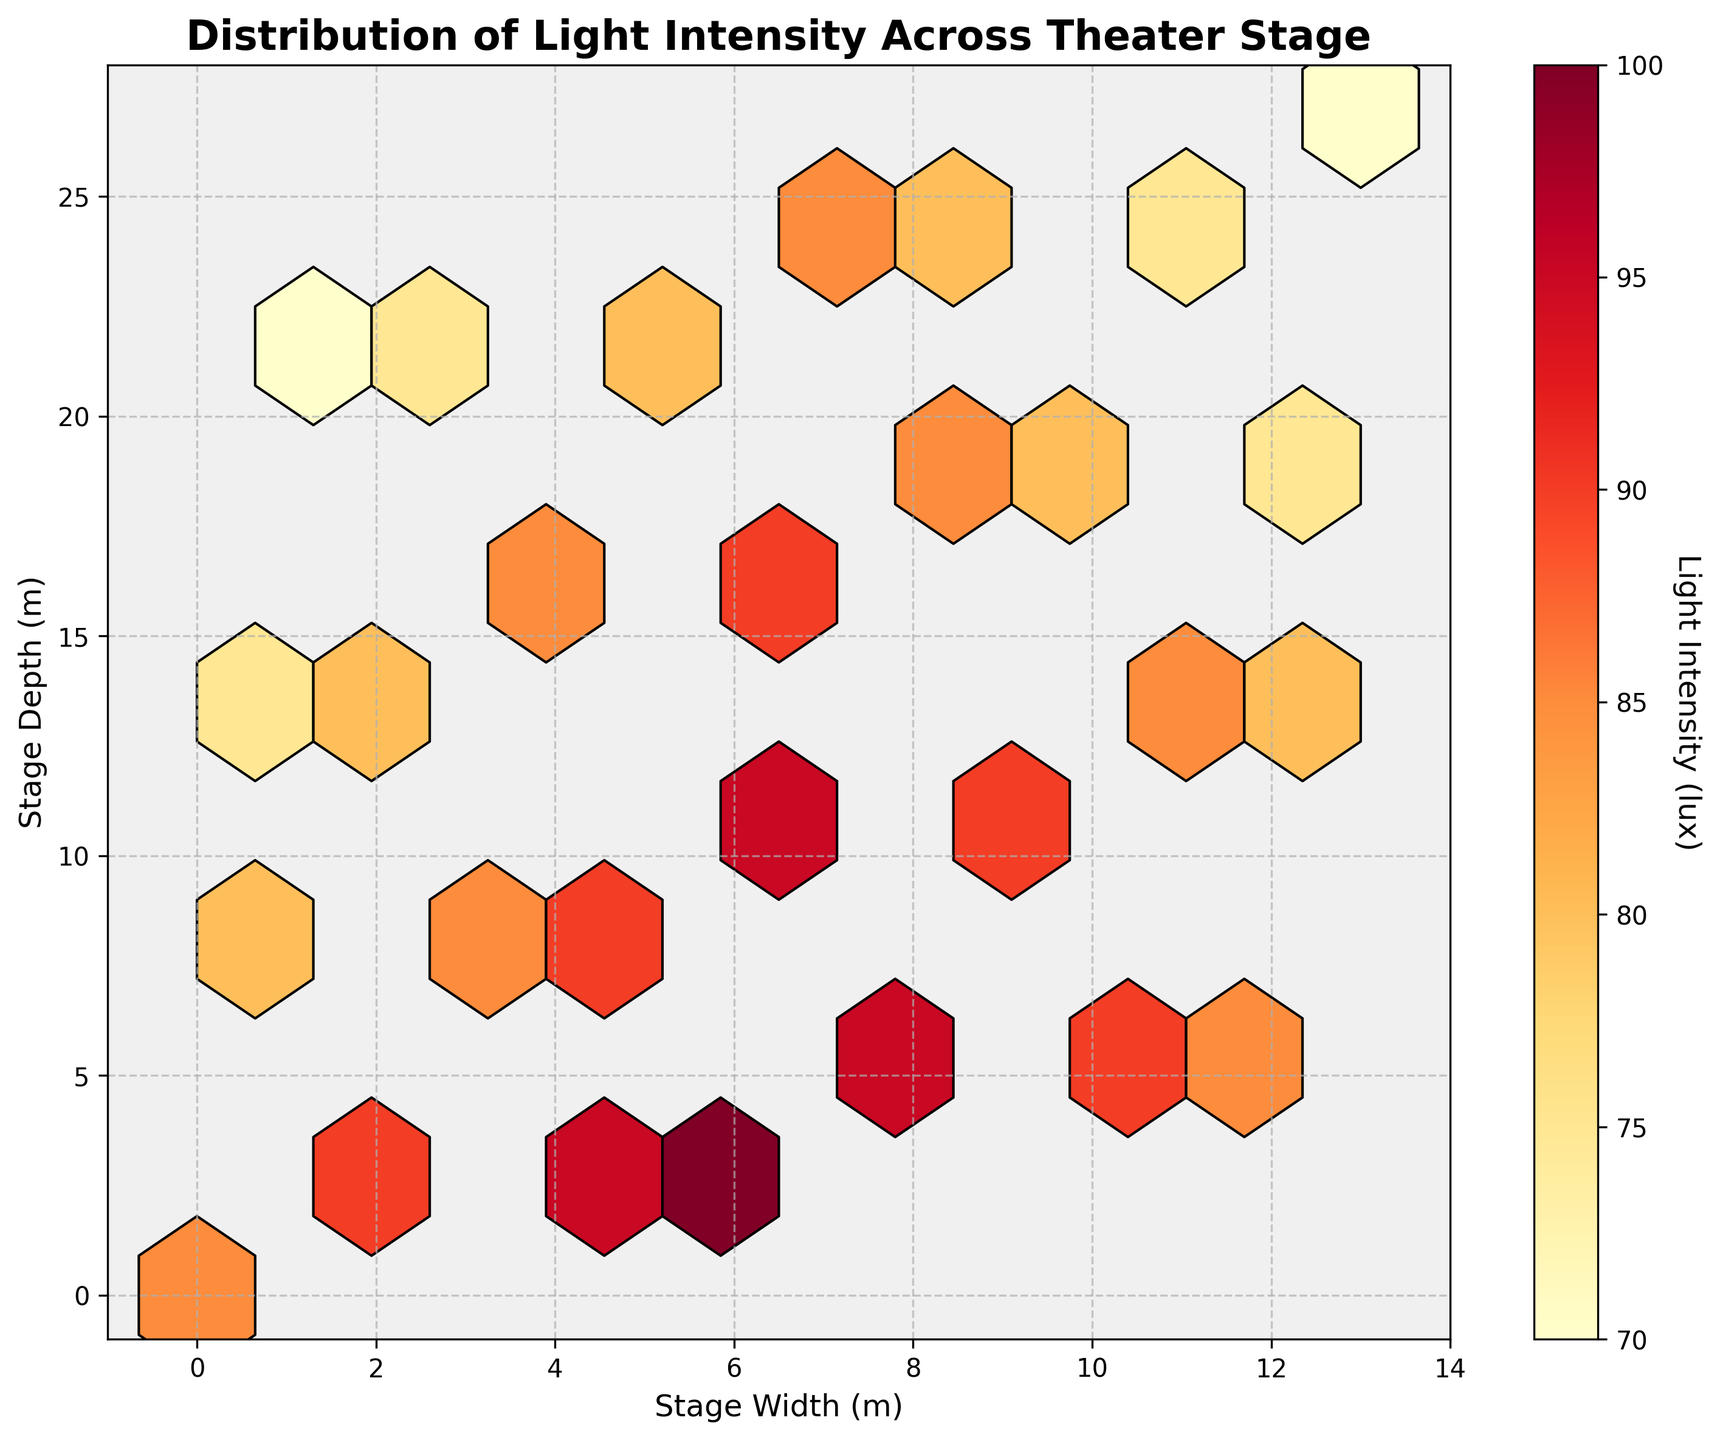What's the title of the figure? The title is found at the top of the figure and summarized the visual content.
Answer: Distribution of Light Intensity Across Theater Stage Which axes represent the stage width and depth? The labels on the axes indicate what they represent; the x-axis is labeled “Stage Width (m)” and the y-axis is labeled “Stage Depth (m).”
Answer: x-axis: Stage Width (m), y-axis: Stage Depth (m) What is the highest light intensity shown in the color bar? The color bar on the side of the figure ranges from the lowest to the highest light intensity values. The highest value shown is at the top of the color band.
Answer: 100 lux In which areas of the stage is the light intensity the highest? Hotspots of light intensity can be identified by regions colored closer to red on the figure.
Answer: Center of the stage How does the intensity near the back of the stage compare to the intensity near the front of the stage? By examining the colors towards the back and front of the stage, we can compare the relative intensities. Yellow and light orange areas are towards the front and darker areas like red towards the center/back.
Answer: The intensity is higher near the center/back than the front Are there any distinct shadows on the stage? Shadows would be represented by areas with lower light intensity, closer to the yellow color.
Answer: Yes, there are shadows around the periphery of the stage What's the average light intensity at the edges of the stage? Look for the intensity values at points near the outer limits of the X and Y axes, average those values: Mean of the intensities at point (0,0), (0,14), (13,0), (13,27).
Answer: 75 lux Is there a significant difference in brightness between the left and right sides of the stage? Comparing the color distribution and intensity values on the left and right extremes of the hexbin plot.
Answer: No significant difference Which region of the stage would you adjust the lighting for better balance? Identify regions that deviate significantly in intensity compared to the surrounding areas to balance; look for stark differences in the color map.
Answer: Regions around the center where intensity exceeds 90 lux Where would you position a spotlight to eliminate shadows? Spotlights should target the darker hexbin regions representing shadows; these regions appear light yellow in the figure.
Answer: Around the edges, especially near the front and sides of the stage 